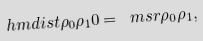<formula> <loc_0><loc_0><loc_500><loc_500>\ h m d i s t { \rho _ { 0 } } { \rho _ { 1 } } { 0 } = \ m s r { \rho _ { 0 } } { \rho _ { 1 } } ,</formula> 